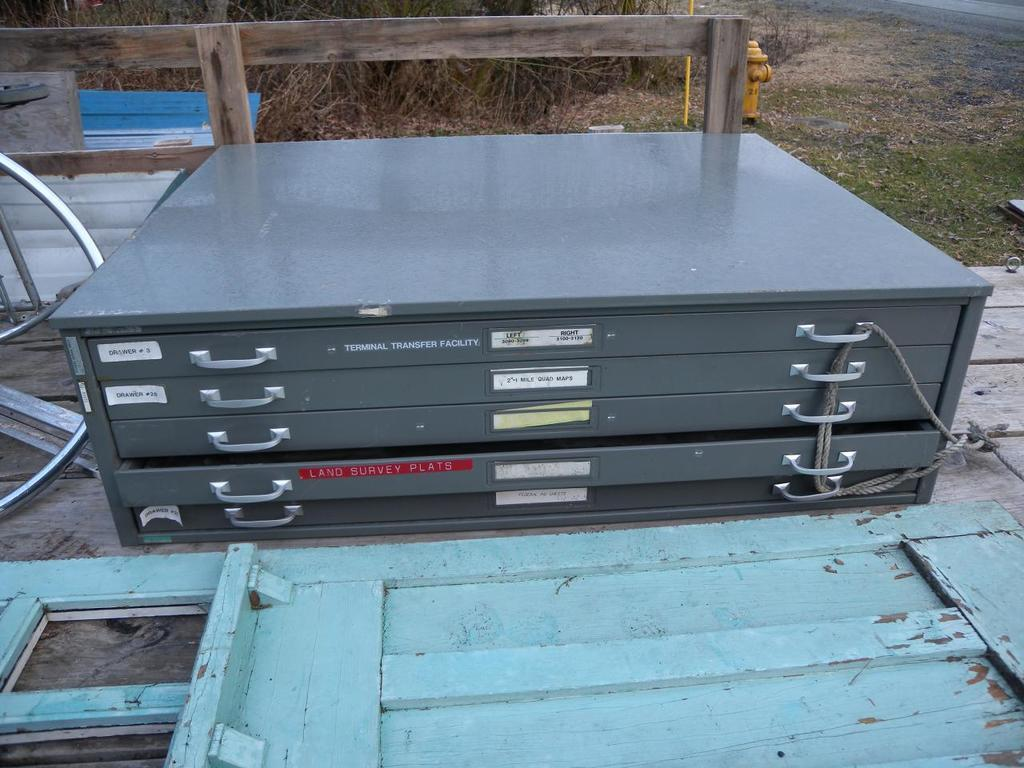<image>
Offer a succinct explanation of the picture presented. A metal box has slender drawers with lables, the red lable indicates there are plats in the drawer. 